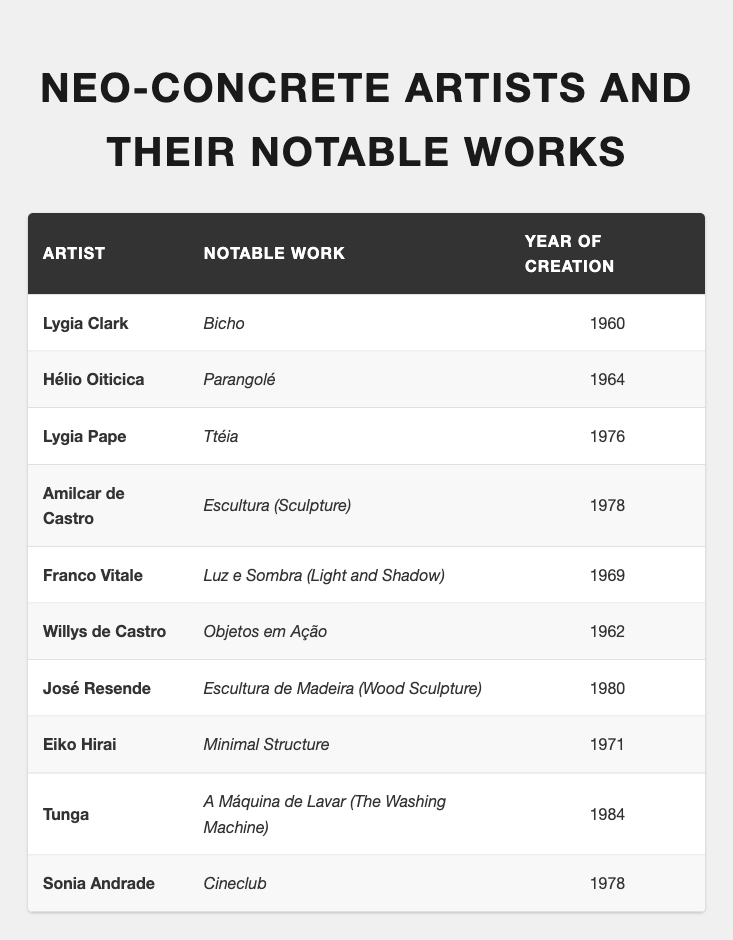What is the year of creation for Lygia Pape's notable work? According to the table, Lygia Pape's notable work "Ttéia" was created in the year 1976.
Answer: 1976 Who created "Parangolé" and in what year? The table shows that "Parangolé" was created by Hélio Oiticica in the year 1964.
Answer: Hélio Oiticica, 1964 Which artist is associated with the notable work "Bicho"? From the table, Lygia Clark is the artist associated with "Bicho".
Answer: Lygia Clark How many works were created in the 1970s? The works created in the 1970s according to the table are "Ttéia" (1976), "Escultura" (1978), "Minimal Structure" (1971), and "Cineclub" (1978). This totals to 4 works.
Answer: 4 What is the earliest notable work listed and who is the artist? The earliest notable work listed is "Bicho", created by Lygia Clark in 1960, which is the first entry in the table.
Answer: "Bicho", Lygia Clark Is "Objetos em Ação" created before or after "Luz e Sombra"? "Objetos em Ação" by Willys de Castro was created in 1962 and "Luz e Sombra" by Franco Vitale was created in 1969. Since 1962 is before 1969, "Objetos em Ação" was created before "Luz e Sombra".
Answer: Before Identify the artist with the latest notable work and name that work. The latest notable work listed is "A Máquina de Lavar" created by Tunga in 1984. This is the last entry in the table.
Answer: Tunga, "A Máquina de Lavar" How many artists have notable works created in the year 1978? The table lists two notable works created in 1978: "Escultura (Sculpture)" by Amilcar de Castro and "Cineclub" by Sonia Andrade. Therefore, there are 2 artists with notable works created that year.
Answer: 2 What is the average year of creation for the notable works listed? To find the average, sum the years (1960 + 1964 + 1976 + 1978 + 1969 + 1962 + 1980 + 1971 + 1984 + 1978 = 1971.8) and divide by the count of works (10). Thus, the average year is approximately 1972.
Answer: 1972 Did Lygia Clark create more than one notable work listed in the table? The table indicates that Lygia Clark only has one notable work listed, "Bicho". Therefore, the answer is no.
Answer: No 